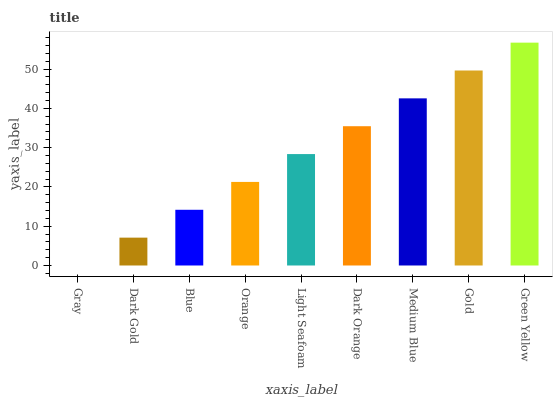Is Gray the minimum?
Answer yes or no. Yes. Is Green Yellow the maximum?
Answer yes or no. Yes. Is Dark Gold the minimum?
Answer yes or no. No. Is Dark Gold the maximum?
Answer yes or no. No. Is Dark Gold greater than Gray?
Answer yes or no. Yes. Is Gray less than Dark Gold?
Answer yes or no. Yes. Is Gray greater than Dark Gold?
Answer yes or no. No. Is Dark Gold less than Gray?
Answer yes or no. No. Is Light Seafoam the high median?
Answer yes or no. Yes. Is Light Seafoam the low median?
Answer yes or no. Yes. Is Dark Gold the high median?
Answer yes or no. No. Is Gray the low median?
Answer yes or no. No. 